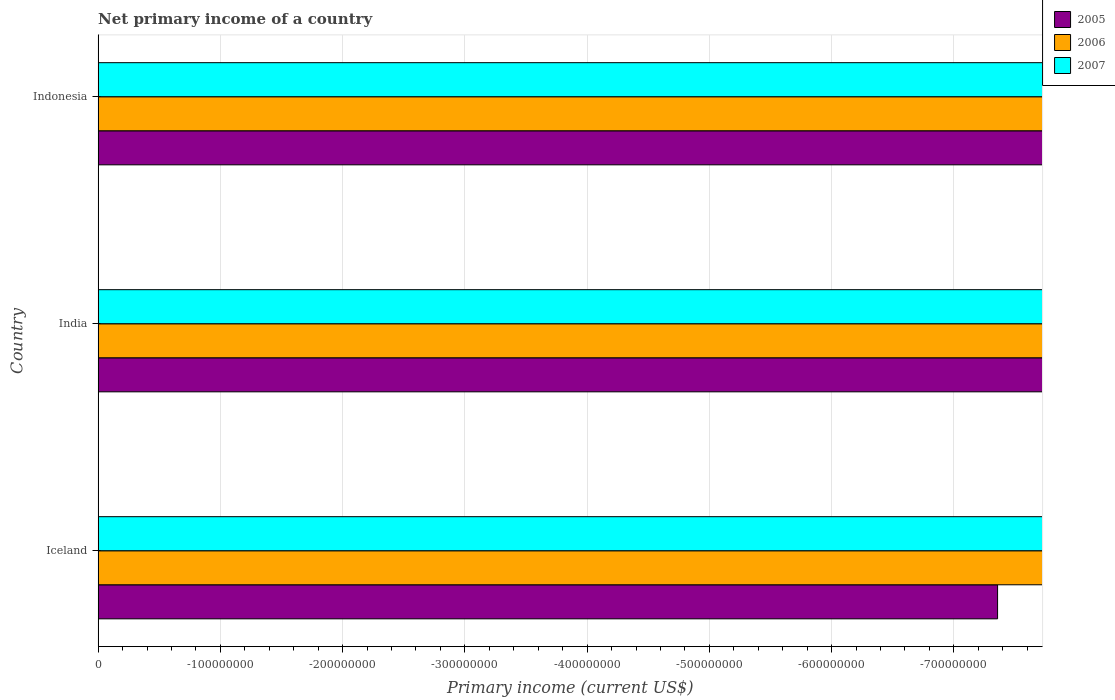How many different coloured bars are there?
Keep it short and to the point. 0. Are the number of bars per tick equal to the number of legend labels?
Offer a very short reply. No. In how many cases, is the number of bars for a given country not equal to the number of legend labels?
Make the answer very short. 3. Across all countries, what is the minimum primary income in 2006?
Offer a terse response. 0. What is the difference between the primary income in 2006 in India and the primary income in 2005 in Indonesia?
Your answer should be compact. 0. What is the average primary income in 2006 per country?
Provide a succinct answer. 0. Is it the case that in every country, the sum of the primary income in 2005 and primary income in 2007 is greater than the primary income in 2006?
Give a very brief answer. No. How many bars are there?
Ensure brevity in your answer.  0. How many countries are there in the graph?
Your response must be concise. 3. Are the values on the major ticks of X-axis written in scientific E-notation?
Keep it short and to the point. No. Does the graph contain any zero values?
Ensure brevity in your answer.  Yes. Does the graph contain grids?
Offer a terse response. Yes. How are the legend labels stacked?
Provide a short and direct response. Vertical. What is the title of the graph?
Provide a succinct answer. Net primary income of a country. Does "1960" appear as one of the legend labels in the graph?
Provide a succinct answer. No. What is the label or title of the X-axis?
Offer a terse response. Primary income (current US$). What is the label or title of the Y-axis?
Offer a very short reply. Country. What is the Primary income (current US$) of 2006 in Iceland?
Provide a short and direct response. 0. What is the Primary income (current US$) in 2007 in Iceland?
Provide a short and direct response. 0. What is the Primary income (current US$) of 2005 in Indonesia?
Ensure brevity in your answer.  0. What is the Primary income (current US$) of 2006 in Indonesia?
Your answer should be compact. 0. What is the Primary income (current US$) of 2007 in Indonesia?
Offer a very short reply. 0. What is the total Primary income (current US$) in 2006 in the graph?
Provide a short and direct response. 0. What is the total Primary income (current US$) of 2007 in the graph?
Give a very brief answer. 0. What is the average Primary income (current US$) in 2006 per country?
Your answer should be compact. 0. What is the average Primary income (current US$) of 2007 per country?
Your answer should be very brief. 0. 